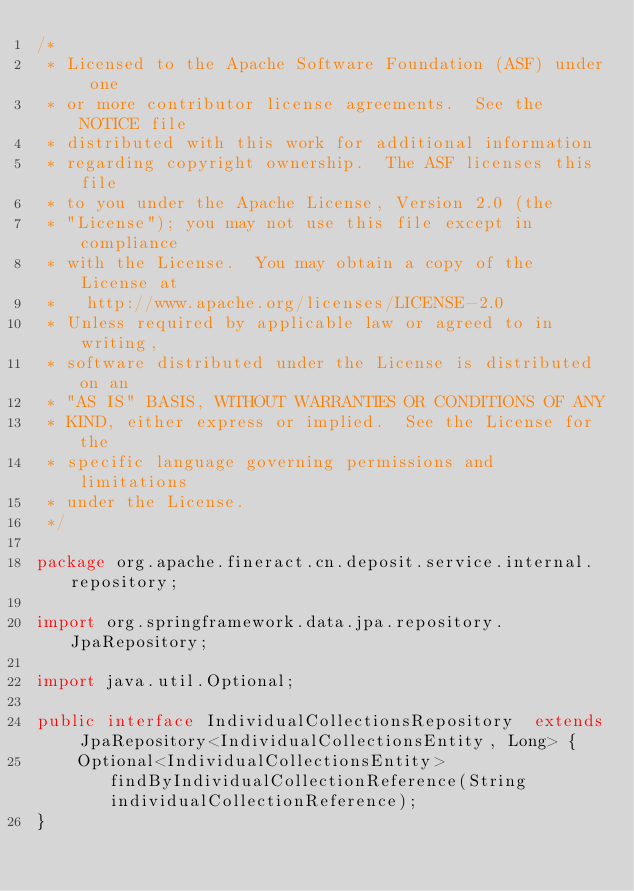<code> <loc_0><loc_0><loc_500><loc_500><_Java_>/*
 * Licensed to the Apache Software Foundation (ASF) under one
 * or more contributor license agreements.  See the NOTICE file
 * distributed with this work for additional information
 * regarding copyright ownership.  The ASF licenses this file
 * to you under the Apache License, Version 2.0 (the
 * "License"); you may not use this file except in compliance
 * with the License.  You may obtain a copy of the License at
 *   http://www.apache.org/licenses/LICENSE-2.0
 * Unless required by applicable law or agreed to in writing,
 * software distributed under the License is distributed on an
 * "AS IS" BASIS, WITHOUT WARRANTIES OR CONDITIONS OF ANY
 * KIND, either express or implied.  See the License for the
 * specific language governing permissions and limitations
 * under the License.
 */

package org.apache.fineract.cn.deposit.service.internal.repository;

import org.springframework.data.jpa.repository.JpaRepository;

import java.util.Optional;

public interface IndividualCollectionsRepository  extends JpaRepository<IndividualCollectionsEntity, Long> {
    Optional<IndividualCollectionsEntity> findByIndividualCollectionReference(String individualCollectionReference);
}
</code> 